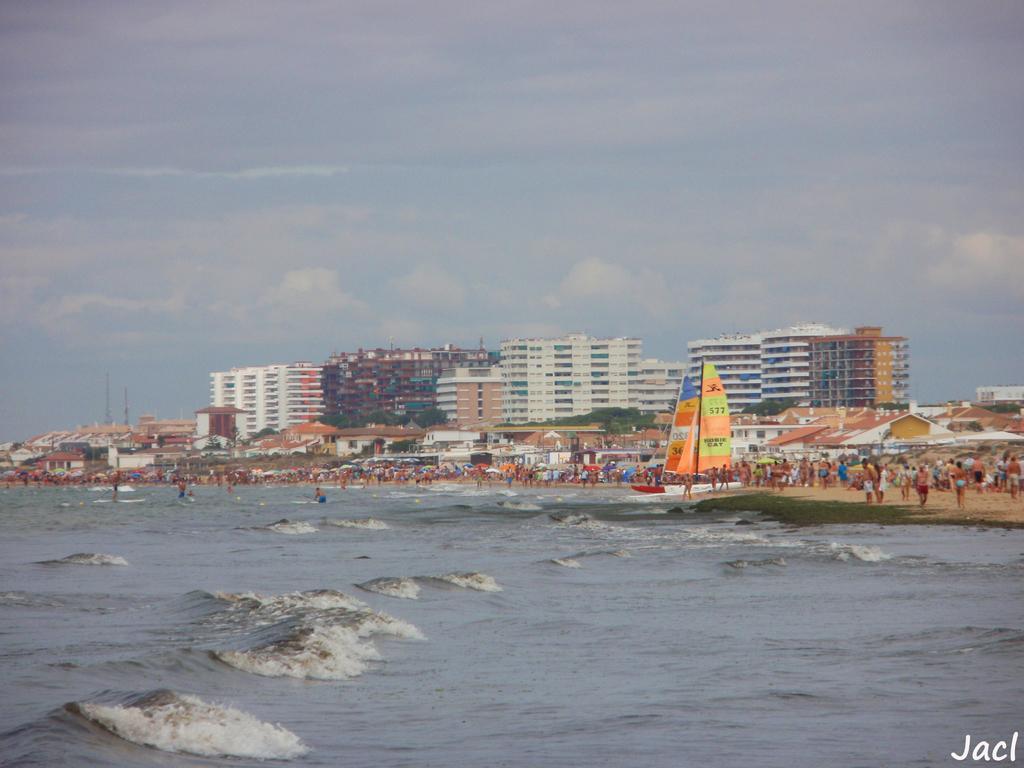Please provide a concise description of this image. This image is clicked near the ocean. At the bottom, there is water, In the background, there are many people. In the middle, we can see the flags. And there are clouds in the sky. In the middle, there are buildings. 